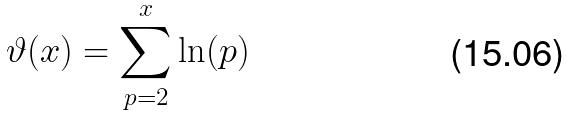<formula> <loc_0><loc_0><loc_500><loc_500>\vartheta ( x ) = \sum _ { p = 2 } ^ { x } \ln ( p )</formula> 